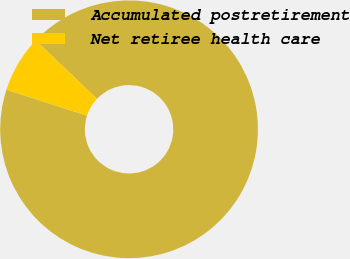Convert chart. <chart><loc_0><loc_0><loc_500><loc_500><pie_chart><fcel>Accumulated postretirement<fcel>Net retiree health care<nl><fcel>92.86%<fcel>7.14%<nl></chart> 